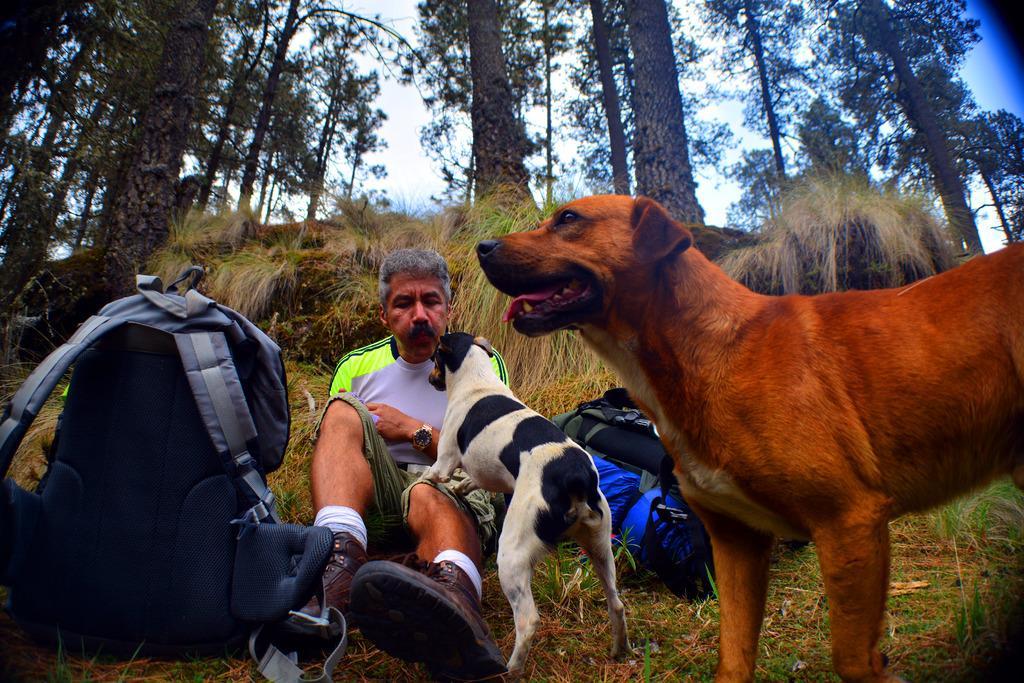Can you describe this image briefly? These are the two dogs at here and a man is playing with the dog and behind him there are trees and it's a bag. 